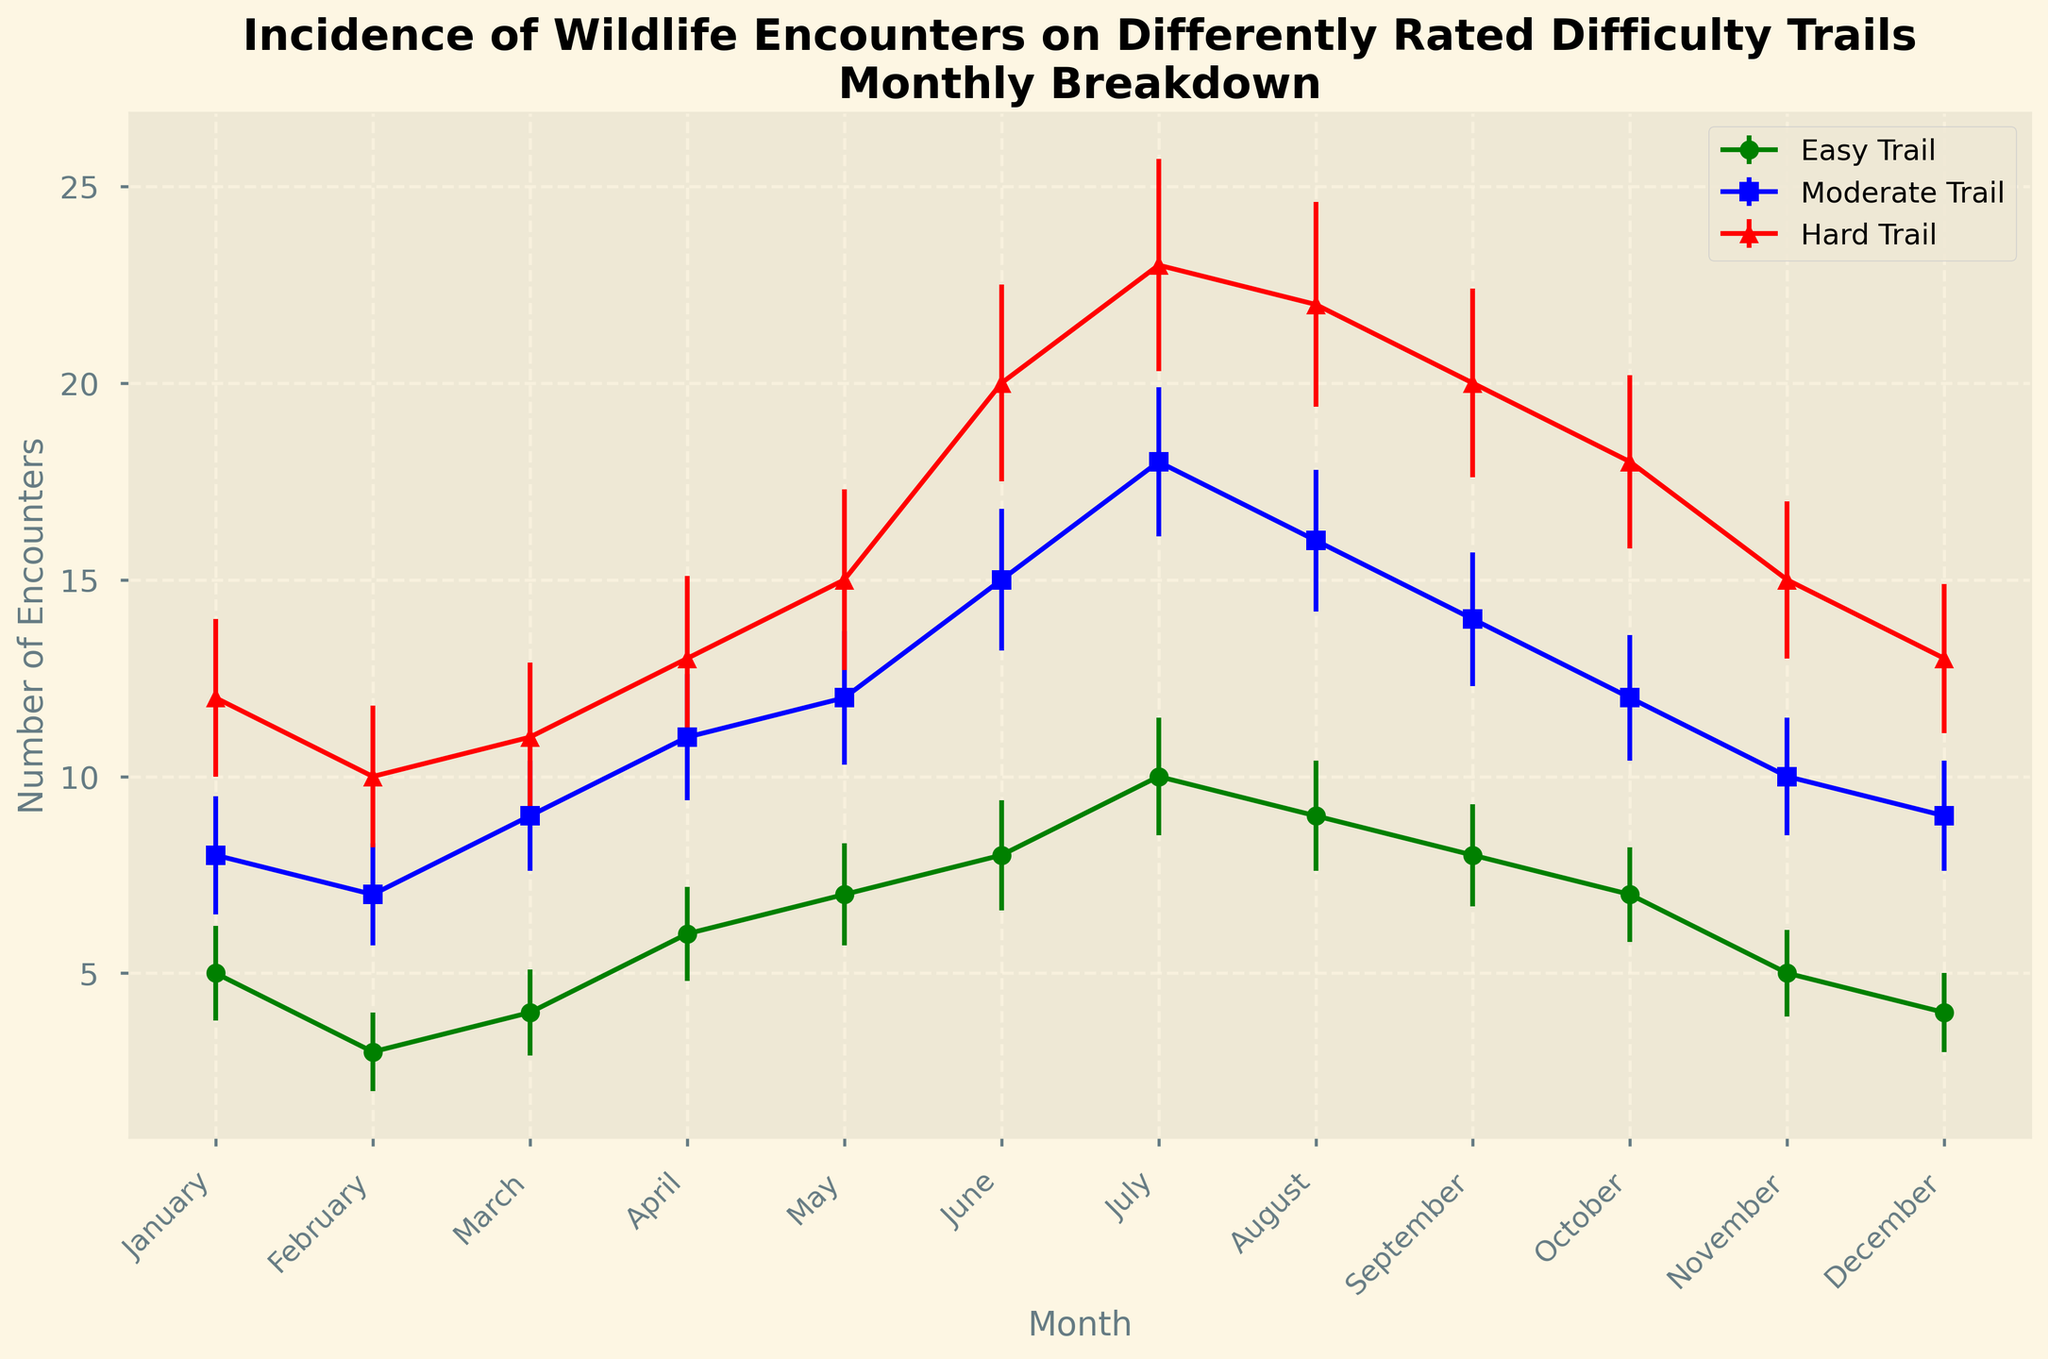What month had the highest incidence of wildlife encounters on the Hard Trail? The month with the highest incidence is the one with the highest point for the Hard Trail (red line) on the plot. Look for the peak in the red line.
Answer: July How do the wildlife encounters on Moderate and Hard trails in June compare? To compare, look at the points for Moderate (blue) and Hard (red) trails for June. Moderate trails have 15 encounters, and Hard trails have 20 encounters. Comparing the values, Hard trails have more.
Answer: Hard trails > Moderate trails Which trail had the least variability in wildlife encounters across the months? Variability can be inferred from the sizes of the error bars. The trail with the smallest average error bars has the least variability. Evaluate and compare the error bars for the Easy (green), Moderate (blue), and Hard (red) trails. The error bars for the Easy trail are generally smaller.
Answer: Easy trail What is the average number of wildlife encounters for Easy, Moderate, and Hard trails in July? July data: Easy (10 encounters), Moderate (18 encounters), Hard (23 encounters). Calculate the average: (10 + 18 + 23) / 3 = 51 / 3 = 17.
Answer: 17 How did the wildlife encounters on the Easy trail change from January to April? Note the encounters in January (5) and April (6). The change is the difference between April and January encounters: 6 - 5 = 1.
Answer: Increased by 1 Which month shows the greatest difference in wildlife encounters between Easy and Moderate trails? Compute the differences for each month and identify the greatest difference: January (3), February (4), March (5), April (5), May (5), June (7), July (8), August (7), September (6), October (5), November (5), December (5). The maximum difference is in July.
Answer: July By how many encounters did the Hard trails exceed the Easy trails in May? May data: Hard trails (15 encounters), Easy trails (7 encounters). Compute the difference: 15 - 7 = 8.
Answer: 8 Are there any months where the wildlife encounters on Moderate and Hard trails are equal? Check each month to see if Moderate (blue) and Hard (red) points align with the same number of encounters. None of the months show an exact match in encounters between the Moderate and Hard trails.
Answer: No Which trail demonstrated the highest increase in wildlife encounters from June to July? Compare June and July values for each trail and calculate the increase. Easy: 10 - 8 = 2, Moderate: 18 - 15 = 3, Hard: 23 - 20 = 3. Both Moderate and Hard trails had the highest increase of 3 encounters.
Answer: Moderate and Hard trails What visual pattern do you observe regarding the relation between trail difficulty and wildlife encounters? As the difficulty increases from Easy (green) to Hard (red), the number of wildlife encounters generally increases, which is visually evident as the lines are higher for harder trails.
Answer: More encounters on harder trails 